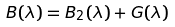Convert formula to latex. <formula><loc_0><loc_0><loc_500><loc_500>B ( \lambda ) = B _ { 2 } ( \lambda ) + G ( \lambda )</formula> 